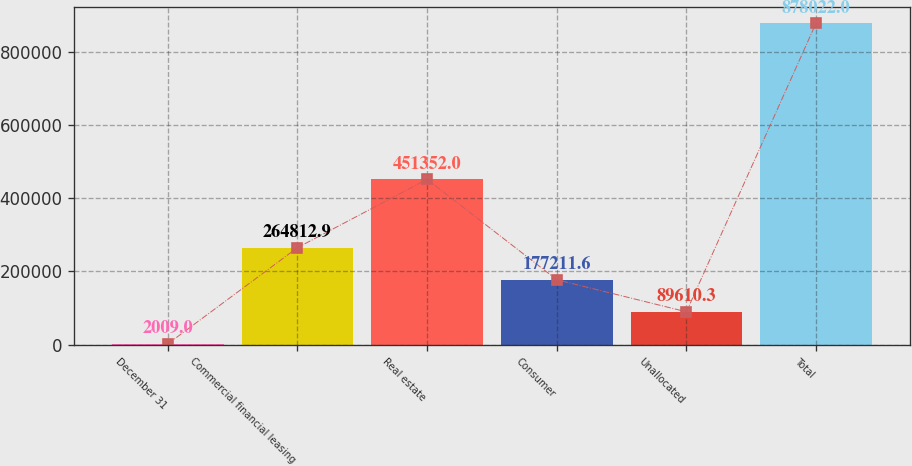Convert chart to OTSL. <chart><loc_0><loc_0><loc_500><loc_500><bar_chart><fcel>December 31<fcel>Commercial financial leasing<fcel>Real estate<fcel>Consumer<fcel>Unallocated<fcel>Total<nl><fcel>2009<fcel>264813<fcel>451352<fcel>177212<fcel>89610.3<fcel>878022<nl></chart> 